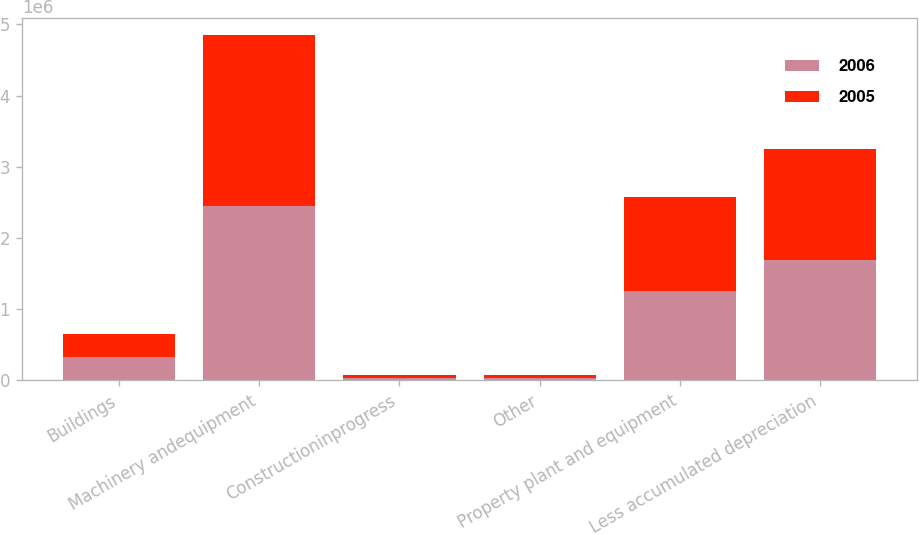Convert chart to OTSL. <chart><loc_0><loc_0><loc_500><loc_500><stacked_bar_chart><ecel><fcel>Buildings<fcel>Machinery andequipment<fcel>Constructioninprogress<fcel>Other<fcel>Property plant and equipment<fcel>Less accumulated depreciation<nl><fcel>2006<fcel>325260<fcel>2.45123e+06<fcel>36211<fcel>33339<fcel>1.25229e+06<fcel>1.68596e+06<nl><fcel>2005<fcel>327223<fcel>2.4014e+06<fcel>34054<fcel>34706<fcel>1.32051e+06<fcel>1.56436e+06<nl></chart> 